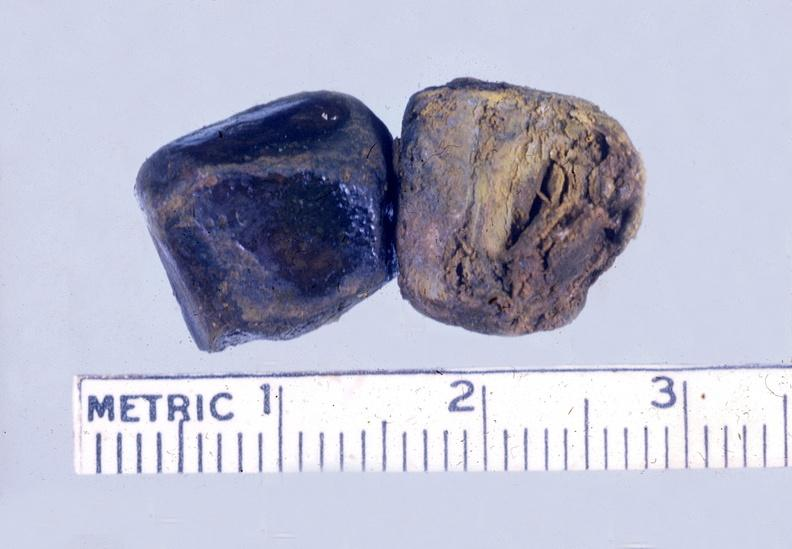s hepatobiliary present?
Answer the question using a single word or phrase. Yes 